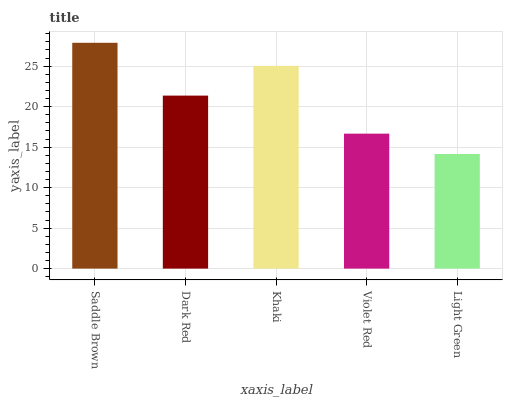Is Light Green the minimum?
Answer yes or no. Yes. Is Saddle Brown the maximum?
Answer yes or no. Yes. Is Dark Red the minimum?
Answer yes or no. No. Is Dark Red the maximum?
Answer yes or no. No. Is Saddle Brown greater than Dark Red?
Answer yes or no. Yes. Is Dark Red less than Saddle Brown?
Answer yes or no. Yes. Is Dark Red greater than Saddle Brown?
Answer yes or no. No. Is Saddle Brown less than Dark Red?
Answer yes or no. No. Is Dark Red the high median?
Answer yes or no. Yes. Is Dark Red the low median?
Answer yes or no. Yes. Is Violet Red the high median?
Answer yes or no. No. Is Violet Red the low median?
Answer yes or no. No. 